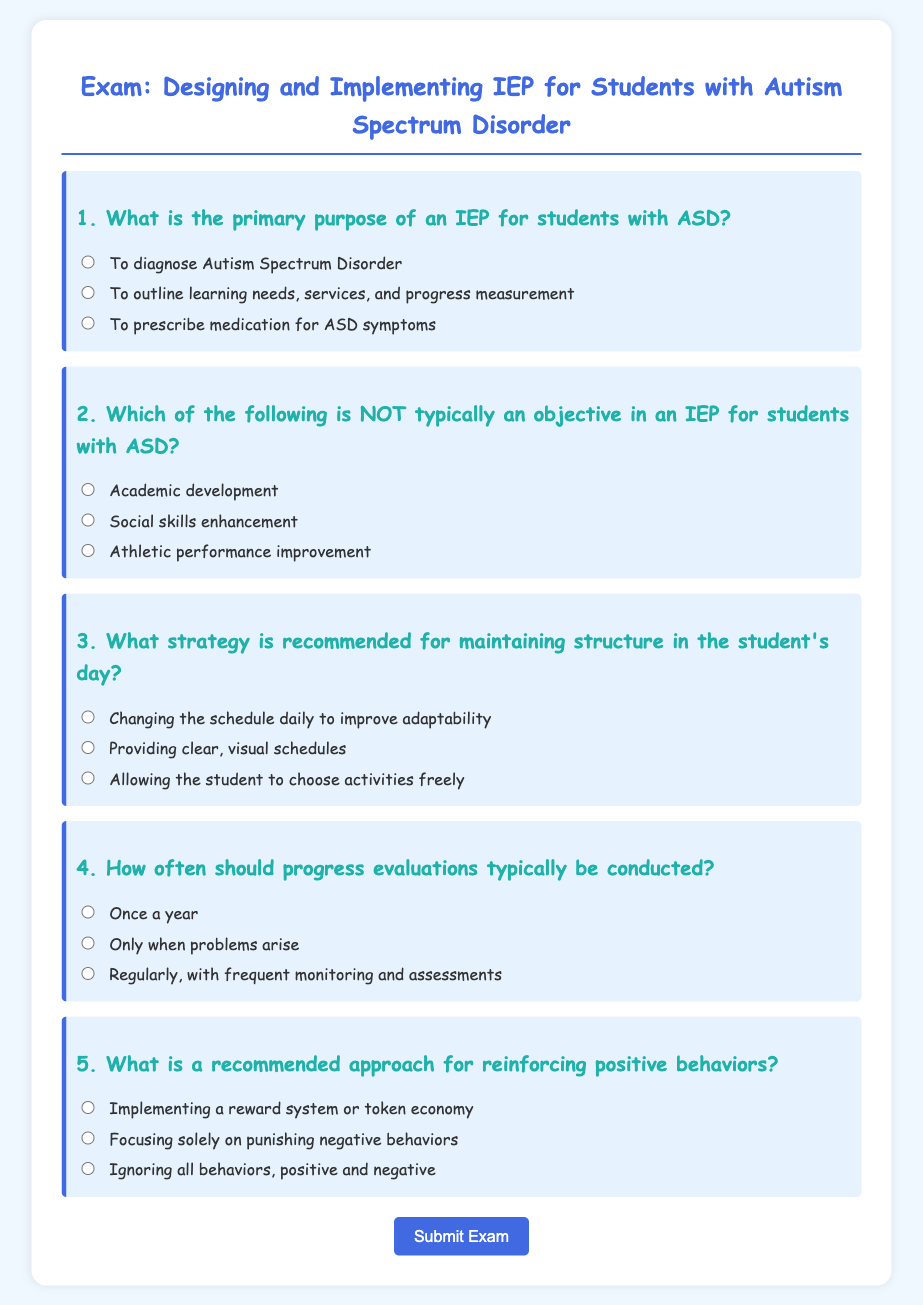What is the title of the document? The title appears at the top of the document, indicating the subject of the exam.
Answer: Exam: Designing and Implementing IEP for Students with Autism Spectrum Disorder How many questions are in the exam? The number of questions can be counted in the format presented in the document.
Answer: 5 What color is used for the main heading (h1)? The document specifies the color code for the heading in the style section.
Answer: #4169e1 What strategy is suggested for maintaining structure in the student's day? The answer is found among the listed strategies in the questions section of the document.
Answer: Providing clear, visual schedules How often should progress evaluations be conducted? The frequency of progress evaluations is identified in one of the exam questions.
Answer: Regularly, with frequent monitoring and assessments What is the purpose of an IEP according to the exam? The purpose is specified in the multiple-choice questions about the IEP.
Answer: To outline learning needs, services, and progress measurement 